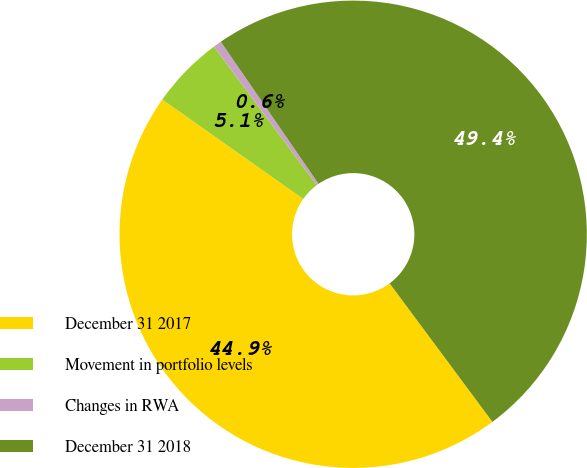Convert chart to OTSL. <chart><loc_0><loc_0><loc_500><loc_500><pie_chart><fcel>December 31 2017<fcel>Movement in portfolio levels<fcel>Changes in RWA<fcel>December 31 2018<nl><fcel>44.94%<fcel>5.06%<fcel>0.57%<fcel>49.43%<nl></chart> 